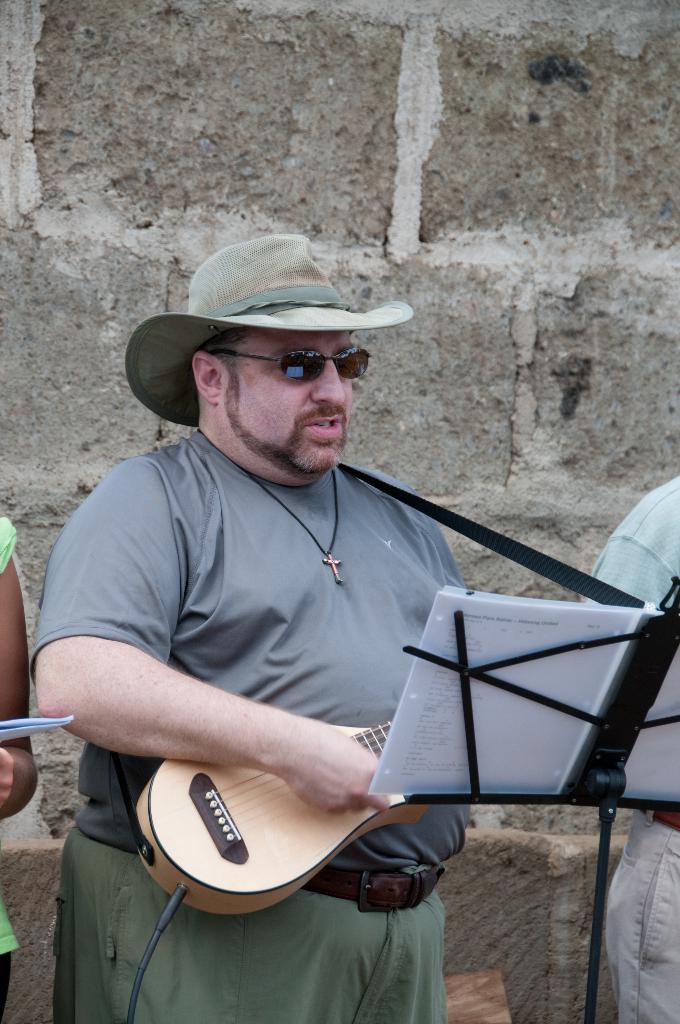Describe this image in one or two sentences. As we can see in the image there is a man wearing hat, spectacles and holding guitar. In front of him there is a paper. 